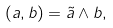Convert formula to latex. <formula><loc_0><loc_0><loc_500><loc_500>( a , b ) = \tilde { a } \wedge b ,</formula> 